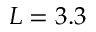<formula> <loc_0><loc_0><loc_500><loc_500>L = 3 . 3</formula> 